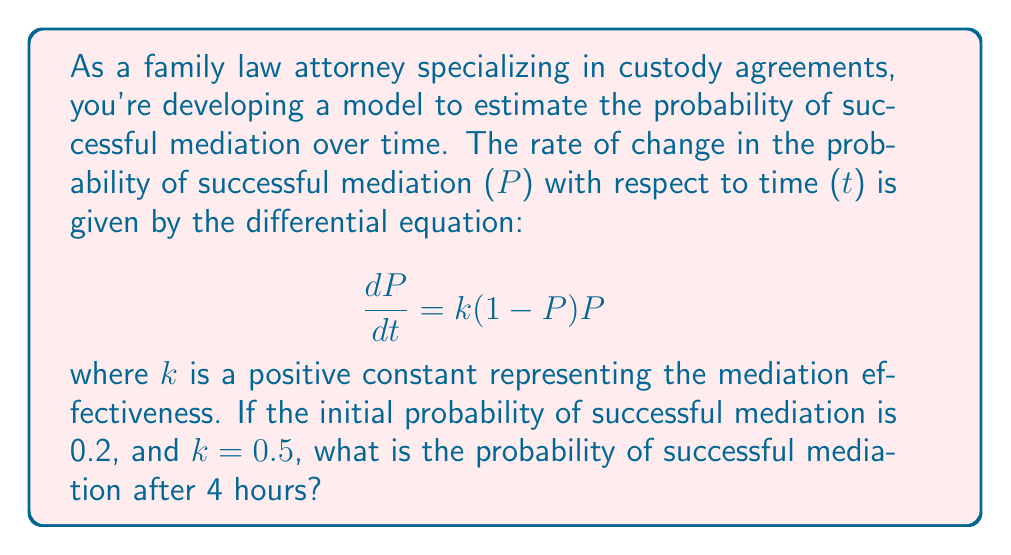Give your solution to this math problem. To solve this problem, we need to follow these steps:

1) The given differential equation is a logistic growth model:
   $$\frac{dP}{dt} = k(1-P)P$$

2) The general solution for this type of equation is:
   $$P(t) = \frac{1}{1 + Ce^{-kt}}$$
   where C is a constant we need to determine from the initial condition.

3) We're given that P(0) = 0.2, so let's use this to find C:
   $$0.2 = \frac{1}{1 + C}$$
   $$1 + C = \frac{1}{0.2} = 5$$
   $$C = 4$$

4) Now we have our specific solution:
   $$P(t) = \frac{1}{1 + 4e^{-0.5t}}$$

5) To find P(4), we simply substitute t = 4:
   $$P(4) = \frac{1}{1 + 4e^{-0.5(4)}}$$
   $$= \frac{1}{1 + 4e^{-2}}$$
   $$= \frac{1}{1 + 4(0.1353)}$$
   $$= \frac{1}{1.5412}$$
   $$\approx 0.6489$$

6) Therefore, the probability of successful mediation after 4 hours is approximately 0.6489 or about 64.89%.
Answer: 0.6489 